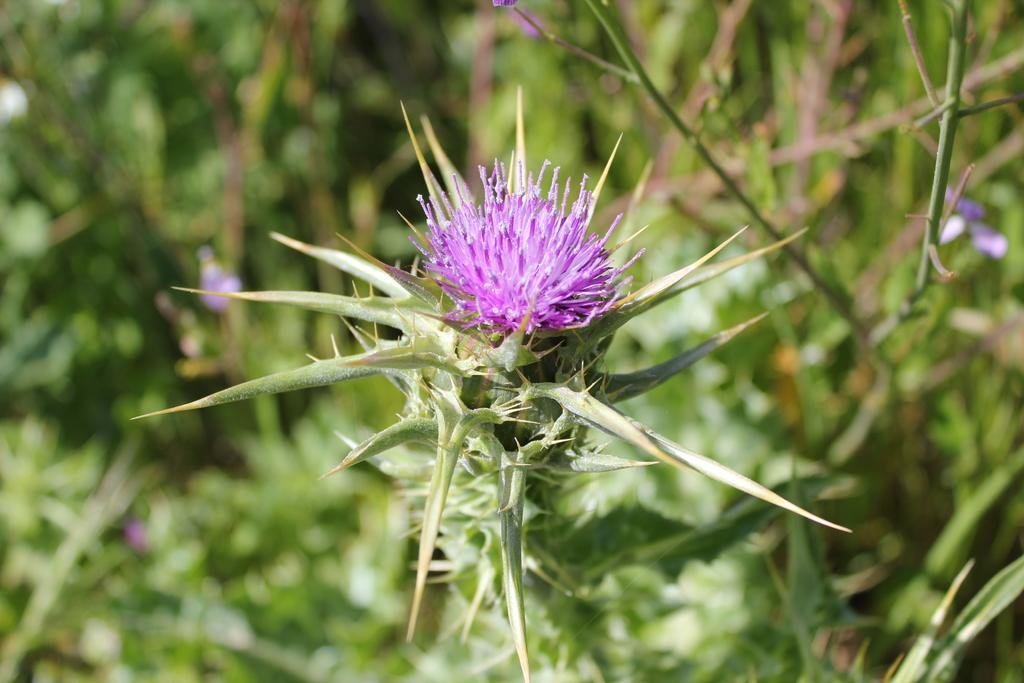What is the main subject of the image? There is a flower in the image. What color is the flower? The flower is violet in color. Where is the flower located? The flower is grown on a plant. What can be seen in the background of the image? There are plants, leaves, and bushes visible in the background of the image. What type of vessel is used to measure the flower's growth in the image? There is no vessel or measurement of the flower's growth present in the image. Is there a pipe visible in the image? No, there is no pipe visible in the image. 